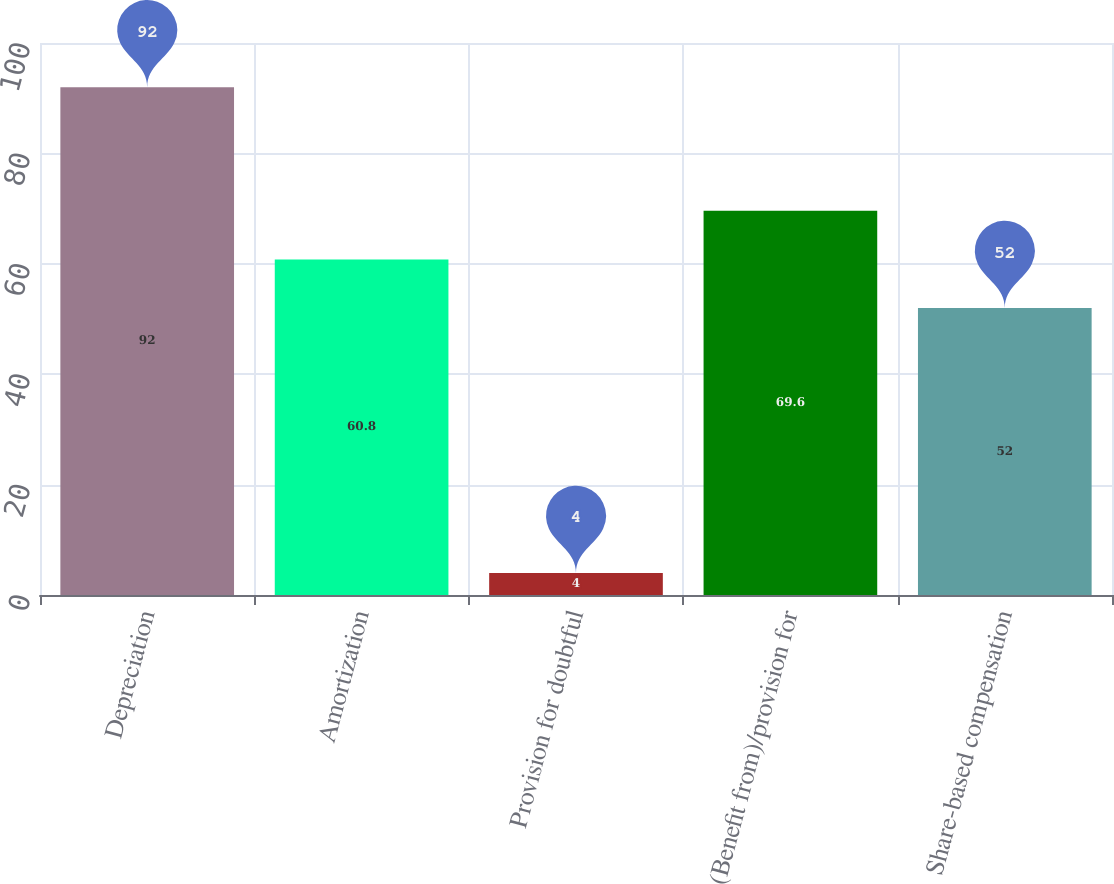Convert chart. <chart><loc_0><loc_0><loc_500><loc_500><bar_chart><fcel>Depreciation<fcel>Amortization<fcel>Provision for doubtful<fcel>(Benefit from)/provision for<fcel>Share-based compensation<nl><fcel>92<fcel>60.8<fcel>4<fcel>69.6<fcel>52<nl></chart> 